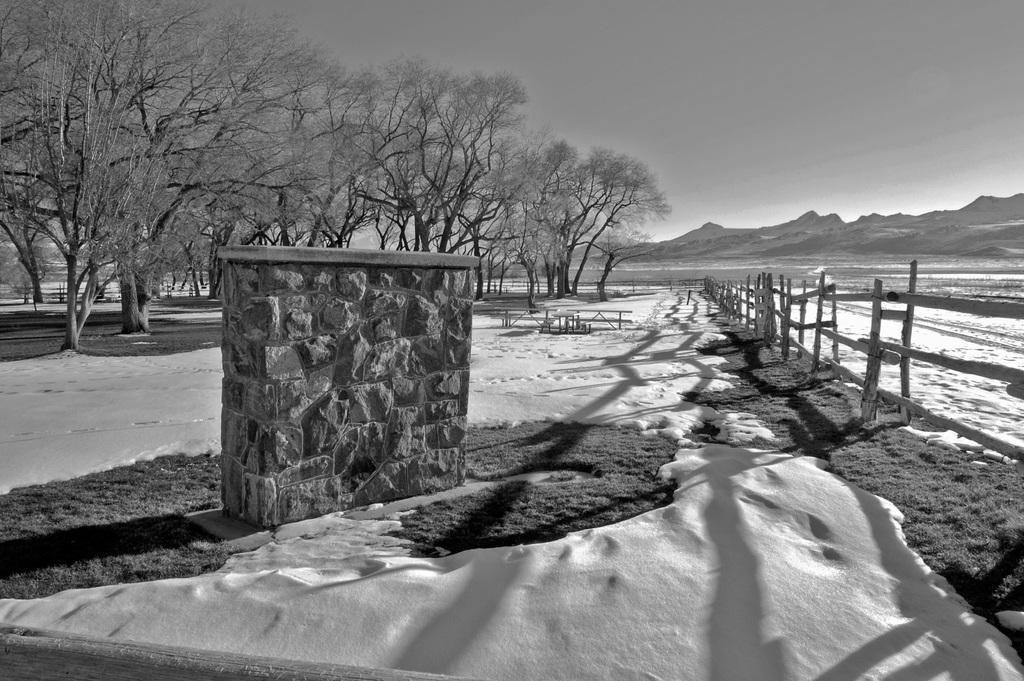In one or two sentences, can you explain what this image depicts? This is a black and white image. At the bottom of the image there is snow. There is a wall. There are trees. In the background of the image there is fencing. To the right side of the image there are mountains. There is sky. 